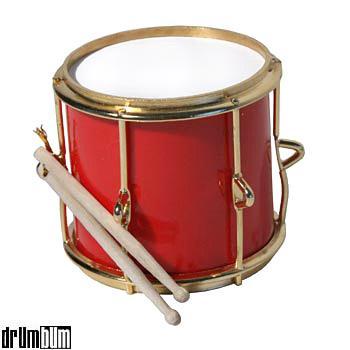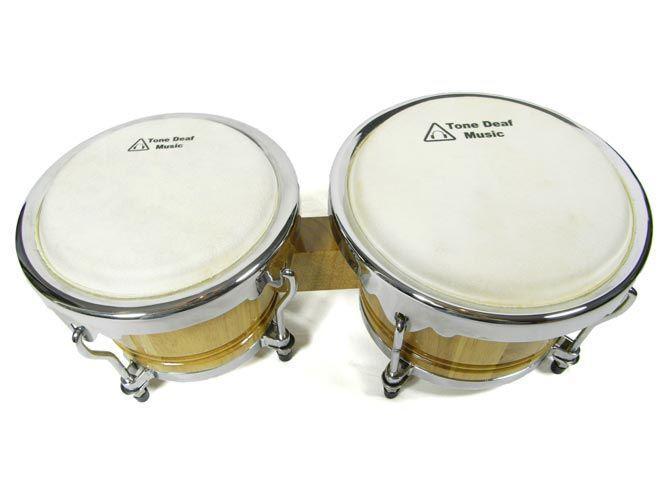The first image is the image on the left, the second image is the image on the right. Assess this claim about the two images: "The right image shows connected drums with solid-colored sides and white tops, and the left image features two drumsticks and a cylinder shape.". Correct or not? Answer yes or no. Yes. The first image is the image on the left, the second image is the image on the right. Assess this claim about the two images: "There are drum sticks in the left image.". Correct or not? Answer yes or no. Yes. 